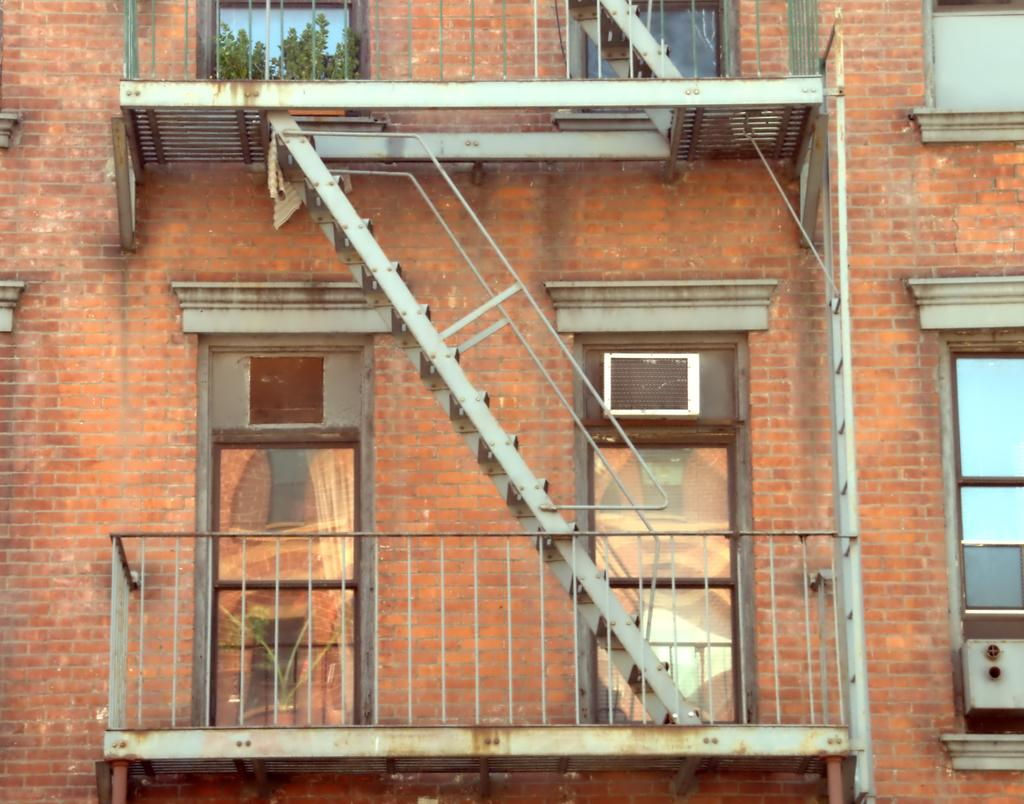What type of structure is in the image? There is a building in the image. What material is used for the walls of the building? The building has brick walls. Are there any openings in the building? Yes, there are windows in the building. What type of construction is visible in the image? There is a metal construction of stairs in the image. Can you describe a specific architectural feature of the building? There is a balcony in the center of the building. What note is being played on the hand in the image? There is no hand or note being played in the image; it features a building with brick walls, windows, a metal construction of stairs, and a balcony. 